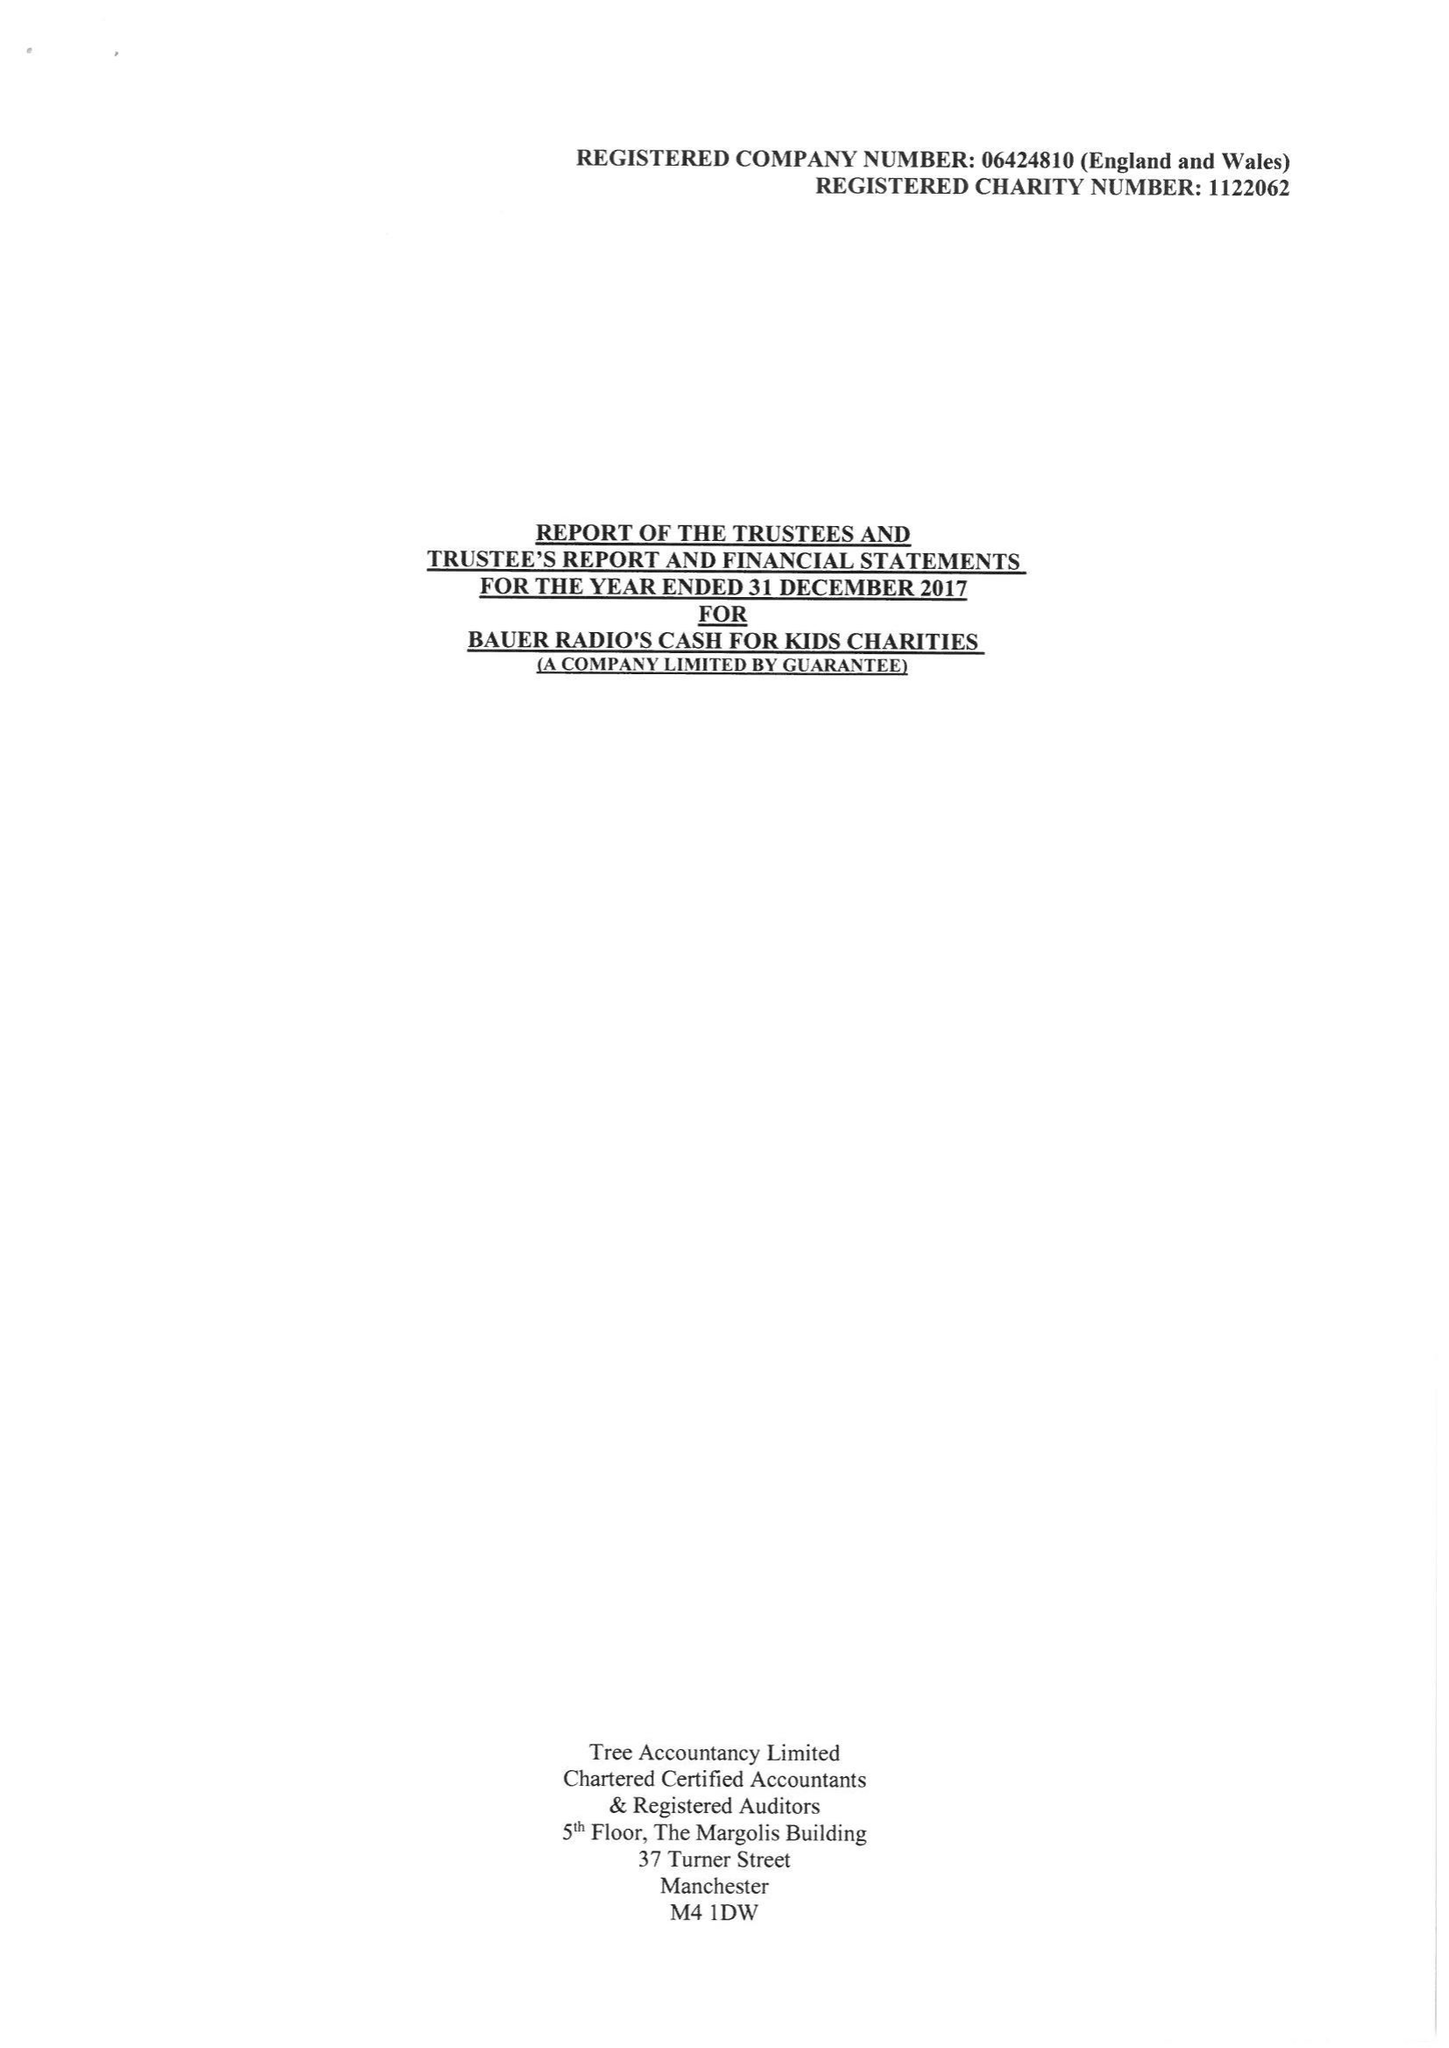What is the value for the charity_number?
Answer the question using a single word or phrase. 1122062 